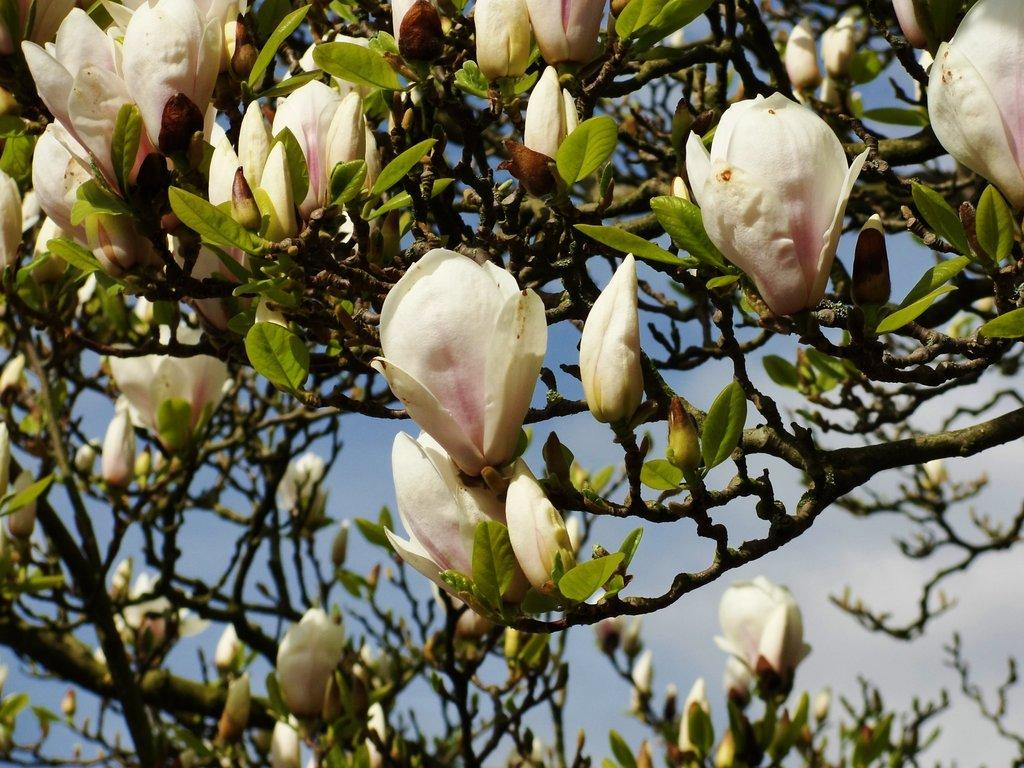What type of plant is visible in the image? The image features a plant with flowers on top. What can be seen in the background of the image? The sky is visible in the background of the image. What is the income of the flowers in the image? The image does not provide information about the income of the flowers, as flowers do not have an income. 